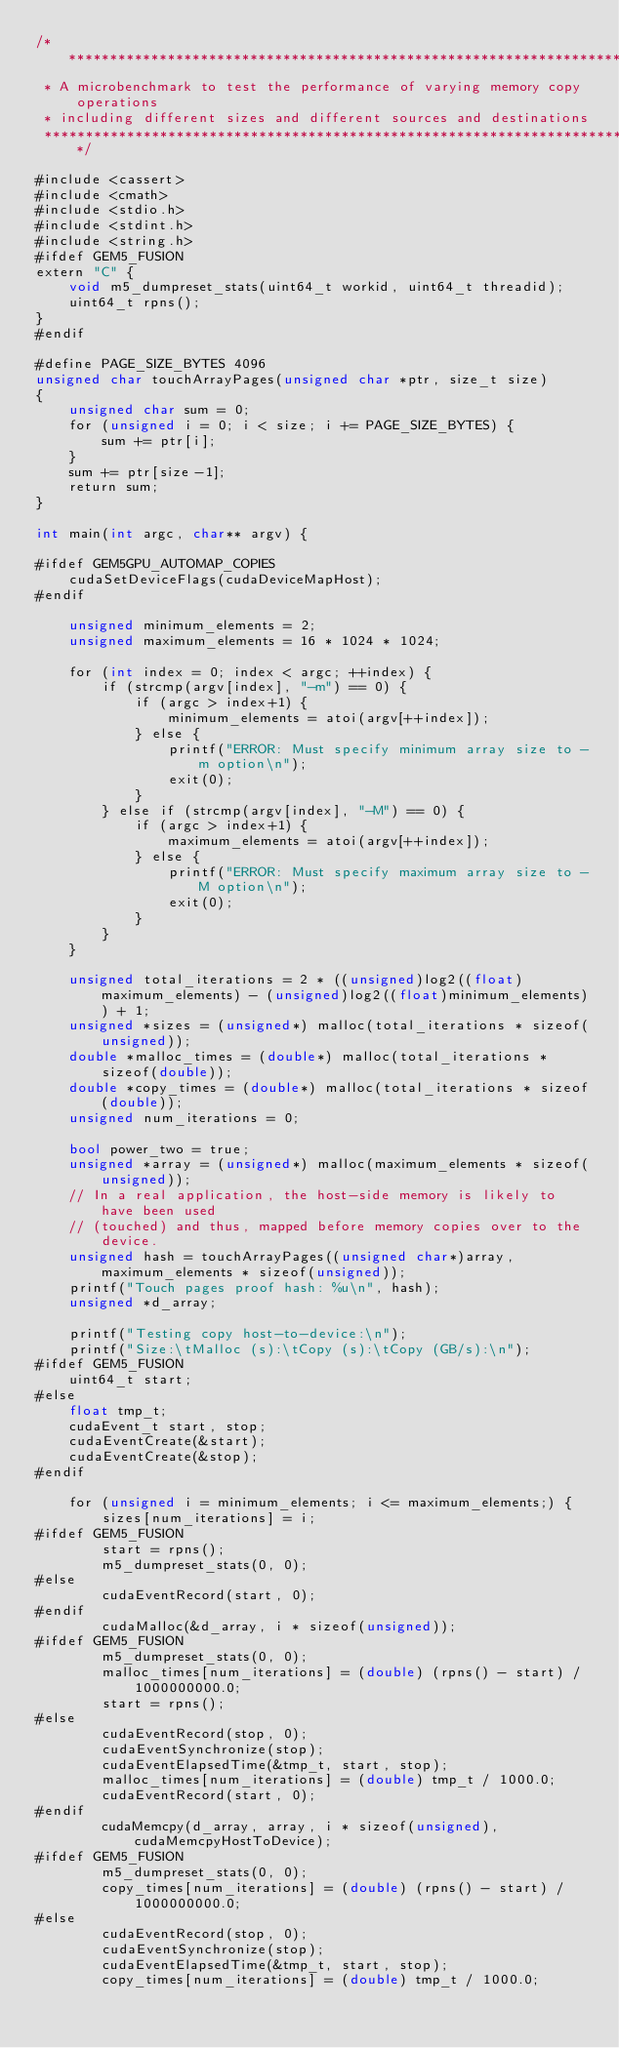<code> <loc_0><loc_0><loc_500><loc_500><_Cuda_>/*****************************************************************************
 * A microbenchmark to test the performance of varying memory copy operations
 * including different sizes and different sources and destinations
 ****************************************************************************/

#include <cassert>
#include <cmath>
#include <stdio.h>
#include <stdint.h>
#include <string.h>
#ifdef GEM5_FUSION
extern "C" {
    void m5_dumpreset_stats(uint64_t workid, uint64_t threadid);
    uint64_t rpns();
}
#endif

#define PAGE_SIZE_BYTES 4096
unsigned char touchArrayPages(unsigned char *ptr, size_t size)
{
    unsigned char sum = 0;
    for (unsigned i = 0; i < size; i += PAGE_SIZE_BYTES) {
        sum += ptr[i];
    }
    sum += ptr[size-1];
    return sum;
}

int main(int argc, char** argv) {

#ifdef GEM5GPU_AUTOMAP_COPIES
    cudaSetDeviceFlags(cudaDeviceMapHost);
#endif

    unsigned minimum_elements = 2;
    unsigned maximum_elements = 16 * 1024 * 1024;

    for (int index = 0; index < argc; ++index) {
        if (strcmp(argv[index], "-m") == 0) {
            if (argc > index+1) {
                minimum_elements = atoi(argv[++index]);
            } else {
                printf("ERROR: Must specify minimum array size to -m option\n");
                exit(0);
            }
        } else if (strcmp(argv[index], "-M") == 0) {
            if (argc > index+1) {
                maximum_elements = atoi(argv[++index]);
            } else {
                printf("ERROR: Must specify maximum array size to -M option\n");
                exit(0);
            }
        }
    }

    unsigned total_iterations = 2 * ((unsigned)log2((float)maximum_elements) - (unsigned)log2((float)minimum_elements)) + 1;
    unsigned *sizes = (unsigned*) malloc(total_iterations * sizeof(unsigned));
    double *malloc_times = (double*) malloc(total_iterations * sizeof(double));
    double *copy_times = (double*) malloc(total_iterations * sizeof(double));
    unsigned num_iterations = 0;

    bool power_two = true;
    unsigned *array = (unsigned*) malloc(maximum_elements * sizeof(unsigned));
    // In a real application, the host-side memory is likely to have been used
    // (touched) and thus, mapped before memory copies over to the device.
    unsigned hash = touchArrayPages((unsigned char*)array, maximum_elements * sizeof(unsigned));
    printf("Touch pages proof hash: %u\n", hash);
    unsigned *d_array;

    printf("Testing copy host-to-device:\n");
    printf("Size:\tMalloc (s):\tCopy (s):\tCopy (GB/s):\n");
#ifdef GEM5_FUSION
    uint64_t start;
#else
    float tmp_t;
    cudaEvent_t start, stop;
    cudaEventCreate(&start);
    cudaEventCreate(&stop);
#endif

    for (unsigned i = minimum_elements; i <= maximum_elements;) {
        sizes[num_iterations] = i;
#ifdef GEM5_FUSION
        start = rpns();
        m5_dumpreset_stats(0, 0);
#else
        cudaEventRecord(start, 0);
#endif
        cudaMalloc(&d_array, i * sizeof(unsigned));
#ifdef GEM5_FUSION
        m5_dumpreset_stats(0, 0);
        malloc_times[num_iterations] = (double) (rpns() - start) / 1000000000.0;
        start = rpns();
#else
        cudaEventRecord(stop, 0);
        cudaEventSynchronize(stop);
        cudaEventElapsedTime(&tmp_t, start, stop);
        malloc_times[num_iterations] = (double) tmp_t / 1000.0;
        cudaEventRecord(start, 0);
#endif
        cudaMemcpy(d_array, array, i * sizeof(unsigned), cudaMemcpyHostToDevice);
#ifdef GEM5_FUSION
        m5_dumpreset_stats(0, 0);
        copy_times[num_iterations] = (double) (rpns() - start) / 1000000000.0;
#else
        cudaEventRecord(stop, 0);
        cudaEventSynchronize(stop);
        cudaEventElapsedTime(&tmp_t, start, stop);
        copy_times[num_iterations] = (double) tmp_t / 1000.0;</code> 